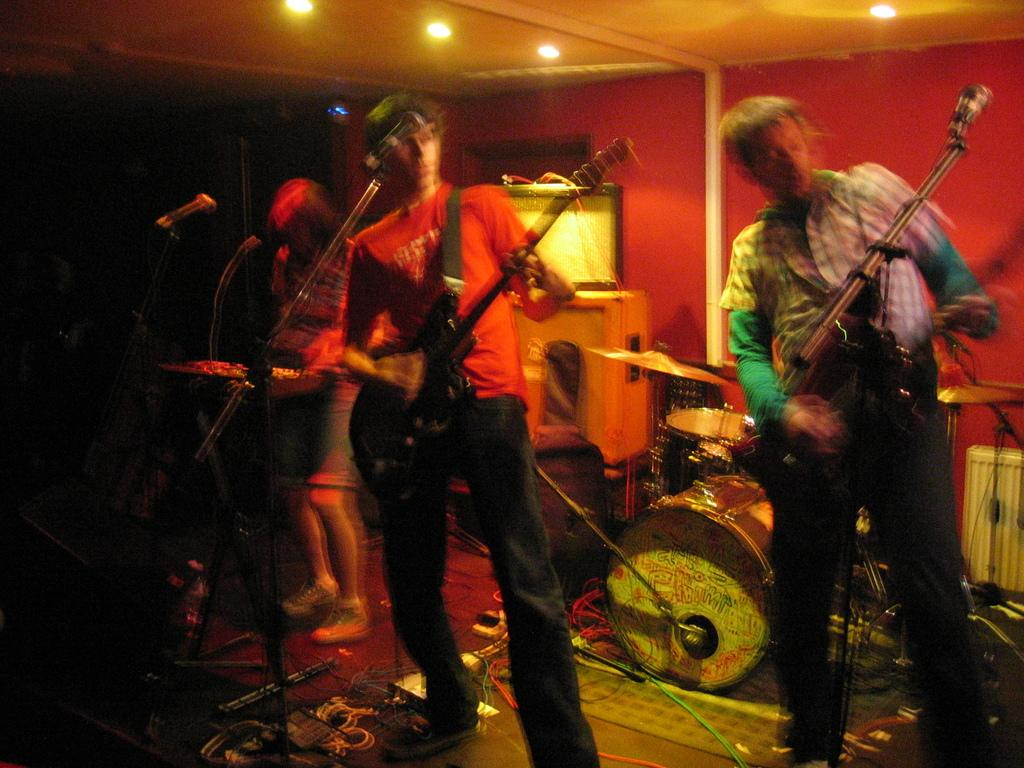What are the people in the image doing? The people in the image are playing musical instruments. What can be seen in the background of the image? There is a wall visible in the image. What else can be seen in the image besides the people and the wall? There are wires, lights, and a ceiling visible in the image. What type of flower is growing on the roof in the image? There is no flower or roof present in the image. What need do the people have for the musical instruments in the image? The image does not provide information about the people's needs or intentions for playing the musical instruments. 